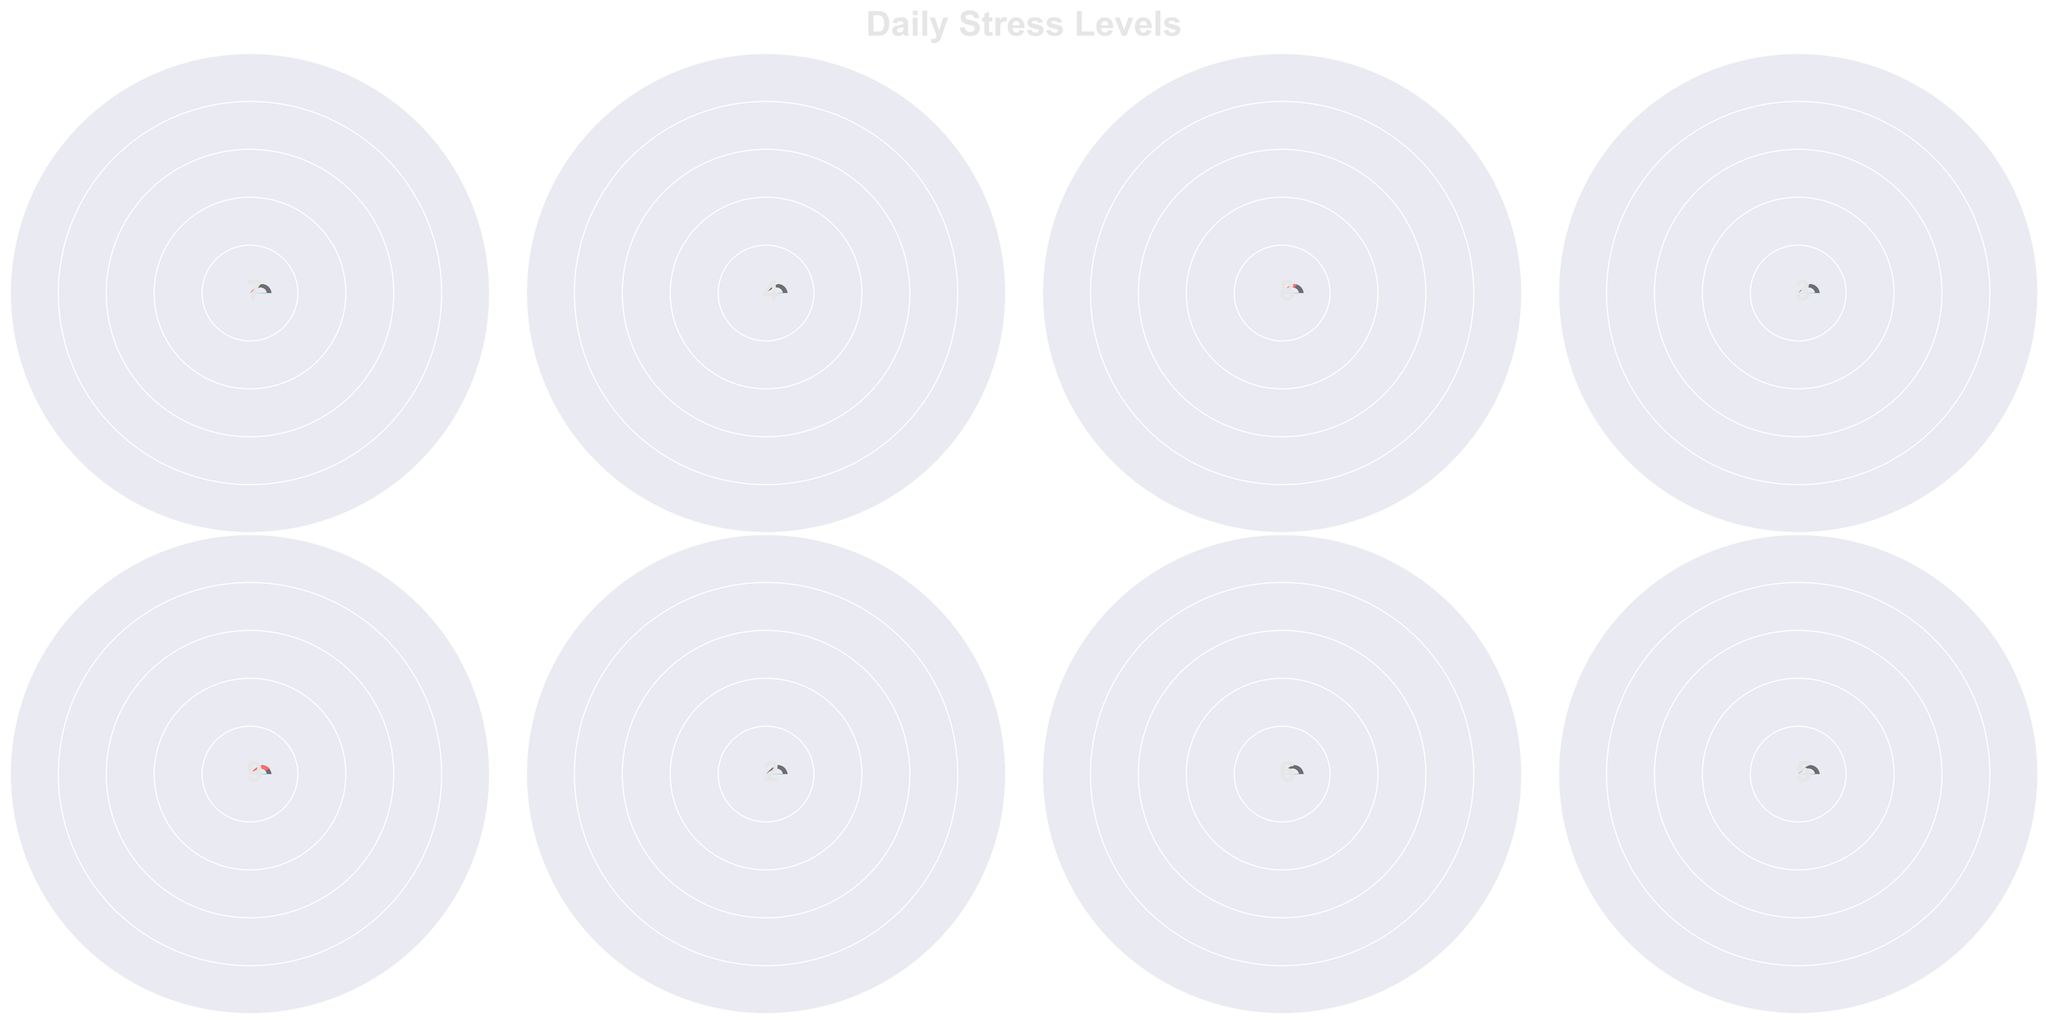What is the overall title of the figure? The overall title is located at the top of the figure and it reads "Daily Stress Levels".
Answer: Daily Stress Levels How many gauge charts are displayed in the figure? By counting the number of individual gauge charts in the figure, we see there are a total of 8 charts.
Answer: 8 Which moment of the day has the highest stress level? The gauge chart for "Post-Nightmare" has the highest value indicated by the gauge, which is 9.
Answer: Post-Nightmare What is the difference in stress levels between "Morning" and "After Music Therapy"? According to the gauge charts, the value for "Morning" is 7 and for "After Music Therapy" is 4. The difference is 7 - 4.
Answer: 3 Which moment has the lowest recorded stress level? The gauge chart for "Weekend Relaxation" shows the lowest value, which is 2.
Answer: Weekend Relaxation How do the stress levels during "Family Time" compare to "Therapy Session"? Family time has a stress level of 3, while Therapy Session shows a stress level of 5. 3 is less than 5.
Answer: Family Time has a lower stress level What is the average stress level of all recorded moments? Sum the stress levels of all moments (7+4+8+3+9+2+6+5) which equals 44, then divide by the number of moments which is 8. 44/8 = 5.5
Answer: 5.5 How does the stress level after "Evening Patrol Memories" compare to "Police Reunion Event"? Evening Patrol Memories has a stress level of 8, while Police Reunion Event has 6. So, Evening Patrol Memories has a higher stress level.
Answer: Evening Patrol Memories has a higher stress level Which moments have a stress level of 4 or lower? By examining the data, "After Music Therapy" (4), "During Family Time" (3), and "Weekend Relaxation" (2) have stress levels of 4 or lower.
Answer: After Music Therapy, During Family Time, Weekend Relaxation What is the median stress level value of all recorded moments? To find the median, first order the values: 2, 3, 4, 5, 6, 7, 8, 9. The median of these 8 values is the average of the 4th and 5th values, (5+6)/2 = 5.5.
Answer: 5.5 